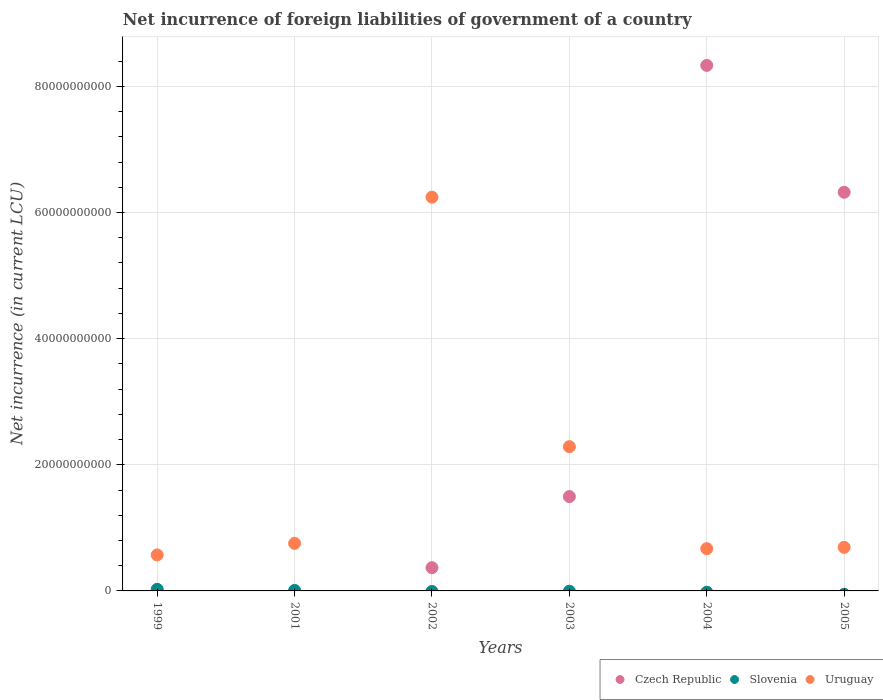Is the number of dotlines equal to the number of legend labels?
Provide a short and direct response. No. What is the net incurrence of foreign liabilities in Uruguay in 2003?
Offer a very short reply. 2.29e+1. Across all years, what is the maximum net incurrence of foreign liabilities in Slovenia?
Provide a succinct answer. 2.56e+08. In which year was the net incurrence of foreign liabilities in Czech Republic maximum?
Your response must be concise. 2004. What is the total net incurrence of foreign liabilities in Uruguay in the graph?
Offer a very short reply. 1.12e+11. What is the difference between the net incurrence of foreign liabilities in Uruguay in 2003 and that in 2005?
Keep it short and to the point. 1.60e+1. What is the difference between the net incurrence of foreign liabilities in Czech Republic in 2002 and the net incurrence of foreign liabilities in Uruguay in 2001?
Make the answer very short. -3.86e+09. What is the average net incurrence of foreign liabilities in Uruguay per year?
Make the answer very short. 1.87e+1. In the year 2005, what is the difference between the net incurrence of foreign liabilities in Czech Republic and net incurrence of foreign liabilities in Uruguay?
Keep it short and to the point. 5.63e+1. What is the ratio of the net incurrence of foreign liabilities in Uruguay in 2001 to that in 2002?
Your answer should be very brief. 0.12. Is the net incurrence of foreign liabilities in Czech Republic in 2002 less than that in 2003?
Offer a terse response. Yes. Is the difference between the net incurrence of foreign liabilities in Czech Republic in 2003 and 2004 greater than the difference between the net incurrence of foreign liabilities in Uruguay in 2003 and 2004?
Your answer should be compact. No. What is the difference between the highest and the second highest net incurrence of foreign liabilities in Czech Republic?
Your answer should be compact. 2.01e+1. What is the difference between the highest and the lowest net incurrence of foreign liabilities in Czech Republic?
Your response must be concise. 8.33e+1. In how many years, is the net incurrence of foreign liabilities in Slovenia greater than the average net incurrence of foreign liabilities in Slovenia taken over all years?
Provide a succinct answer. 2. Is it the case that in every year, the sum of the net incurrence of foreign liabilities in Uruguay and net incurrence of foreign liabilities in Slovenia  is greater than the net incurrence of foreign liabilities in Czech Republic?
Your response must be concise. No. Is the net incurrence of foreign liabilities in Czech Republic strictly less than the net incurrence of foreign liabilities in Slovenia over the years?
Offer a terse response. No. Does the graph contain any zero values?
Give a very brief answer. Yes. How are the legend labels stacked?
Your response must be concise. Horizontal. What is the title of the graph?
Keep it short and to the point. Net incurrence of foreign liabilities of government of a country. What is the label or title of the Y-axis?
Your response must be concise. Net incurrence (in current LCU). What is the Net incurrence (in current LCU) in Czech Republic in 1999?
Provide a short and direct response. 0. What is the Net incurrence (in current LCU) in Slovenia in 1999?
Provide a short and direct response. 2.56e+08. What is the Net incurrence (in current LCU) in Uruguay in 1999?
Offer a terse response. 5.71e+09. What is the Net incurrence (in current LCU) of Slovenia in 2001?
Give a very brief answer. 8.32e+07. What is the Net incurrence (in current LCU) in Uruguay in 2001?
Provide a succinct answer. 7.54e+09. What is the Net incurrence (in current LCU) in Czech Republic in 2002?
Your answer should be compact. 3.68e+09. What is the Net incurrence (in current LCU) of Uruguay in 2002?
Offer a very short reply. 6.24e+1. What is the Net incurrence (in current LCU) in Czech Republic in 2003?
Your response must be concise. 1.50e+1. What is the Net incurrence (in current LCU) of Uruguay in 2003?
Provide a succinct answer. 2.29e+1. What is the Net incurrence (in current LCU) of Czech Republic in 2004?
Offer a terse response. 8.33e+1. What is the Net incurrence (in current LCU) of Uruguay in 2004?
Offer a terse response. 6.70e+09. What is the Net incurrence (in current LCU) of Czech Republic in 2005?
Provide a short and direct response. 6.32e+1. What is the Net incurrence (in current LCU) in Uruguay in 2005?
Provide a succinct answer. 6.91e+09. Across all years, what is the maximum Net incurrence (in current LCU) of Czech Republic?
Keep it short and to the point. 8.33e+1. Across all years, what is the maximum Net incurrence (in current LCU) of Slovenia?
Provide a short and direct response. 2.56e+08. Across all years, what is the maximum Net incurrence (in current LCU) of Uruguay?
Your answer should be very brief. 6.24e+1. Across all years, what is the minimum Net incurrence (in current LCU) in Czech Republic?
Your response must be concise. 0. Across all years, what is the minimum Net incurrence (in current LCU) in Slovenia?
Your answer should be compact. 0. Across all years, what is the minimum Net incurrence (in current LCU) of Uruguay?
Your answer should be compact. 5.71e+09. What is the total Net incurrence (in current LCU) of Czech Republic in the graph?
Provide a succinct answer. 1.65e+11. What is the total Net incurrence (in current LCU) in Slovenia in the graph?
Give a very brief answer. 3.39e+08. What is the total Net incurrence (in current LCU) of Uruguay in the graph?
Offer a terse response. 1.12e+11. What is the difference between the Net incurrence (in current LCU) in Slovenia in 1999 and that in 2001?
Offer a very short reply. 1.73e+08. What is the difference between the Net incurrence (in current LCU) of Uruguay in 1999 and that in 2001?
Provide a short and direct response. -1.83e+09. What is the difference between the Net incurrence (in current LCU) of Uruguay in 1999 and that in 2002?
Your answer should be very brief. -5.67e+1. What is the difference between the Net incurrence (in current LCU) of Uruguay in 1999 and that in 2003?
Your answer should be very brief. -1.72e+1. What is the difference between the Net incurrence (in current LCU) of Uruguay in 1999 and that in 2004?
Your answer should be compact. -9.94e+08. What is the difference between the Net incurrence (in current LCU) in Uruguay in 1999 and that in 2005?
Offer a very short reply. -1.21e+09. What is the difference between the Net incurrence (in current LCU) of Uruguay in 2001 and that in 2002?
Offer a very short reply. -5.49e+1. What is the difference between the Net incurrence (in current LCU) of Uruguay in 2001 and that in 2003?
Provide a short and direct response. -1.53e+1. What is the difference between the Net incurrence (in current LCU) in Uruguay in 2001 and that in 2004?
Provide a succinct answer. 8.39e+08. What is the difference between the Net incurrence (in current LCU) in Uruguay in 2001 and that in 2005?
Your answer should be very brief. 6.27e+08. What is the difference between the Net incurrence (in current LCU) of Czech Republic in 2002 and that in 2003?
Your response must be concise. -1.13e+1. What is the difference between the Net incurrence (in current LCU) of Uruguay in 2002 and that in 2003?
Keep it short and to the point. 3.96e+1. What is the difference between the Net incurrence (in current LCU) in Czech Republic in 2002 and that in 2004?
Make the answer very short. -7.96e+1. What is the difference between the Net incurrence (in current LCU) of Uruguay in 2002 and that in 2004?
Offer a very short reply. 5.57e+1. What is the difference between the Net incurrence (in current LCU) of Czech Republic in 2002 and that in 2005?
Provide a short and direct response. -5.95e+1. What is the difference between the Net incurrence (in current LCU) of Uruguay in 2002 and that in 2005?
Provide a succinct answer. 5.55e+1. What is the difference between the Net incurrence (in current LCU) of Czech Republic in 2003 and that in 2004?
Keep it short and to the point. -6.84e+1. What is the difference between the Net incurrence (in current LCU) of Uruguay in 2003 and that in 2004?
Your response must be concise. 1.62e+1. What is the difference between the Net incurrence (in current LCU) in Czech Republic in 2003 and that in 2005?
Make the answer very short. -4.83e+1. What is the difference between the Net incurrence (in current LCU) of Uruguay in 2003 and that in 2005?
Provide a short and direct response. 1.60e+1. What is the difference between the Net incurrence (in current LCU) of Czech Republic in 2004 and that in 2005?
Make the answer very short. 2.01e+1. What is the difference between the Net incurrence (in current LCU) of Uruguay in 2004 and that in 2005?
Make the answer very short. -2.11e+08. What is the difference between the Net incurrence (in current LCU) of Slovenia in 1999 and the Net incurrence (in current LCU) of Uruguay in 2001?
Offer a very short reply. -7.28e+09. What is the difference between the Net incurrence (in current LCU) of Slovenia in 1999 and the Net incurrence (in current LCU) of Uruguay in 2002?
Your answer should be very brief. -6.22e+1. What is the difference between the Net incurrence (in current LCU) of Slovenia in 1999 and the Net incurrence (in current LCU) of Uruguay in 2003?
Provide a short and direct response. -2.26e+1. What is the difference between the Net incurrence (in current LCU) in Slovenia in 1999 and the Net incurrence (in current LCU) in Uruguay in 2004?
Provide a succinct answer. -6.45e+09. What is the difference between the Net incurrence (in current LCU) of Slovenia in 1999 and the Net incurrence (in current LCU) of Uruguay in 2005?
Your response must be concise. -6.66e+09. What is the difference between the Net incurrence (in current LCU) of Slovenia in 2001 and the Net incurrence (in current LCU) of Uruguay in 2002?
Provide a succinct answer. -6.23e+1. What is the difference between the Net incurrence (in current LCU) in Slovenia in 2001 and the Net incurrence (in current LCU) in Uruguay in 2003?
Your answer should be very brief. -2.28e+1. What is the difference between the Net incurrence (in current LCU) in Slovenia in 2001 and the Net incurrence (in current LCU) in Uruguay in 2004?
Provide a succinct answer. -6.62e+09. What is the difference between the Net incurrence (in current LCU) of Slovenia in 2001 and the Net incurrence (in current LCU) of Uruguay in 2005?
Make the answer very short. -6.83e+09. What is the difference between the Net incurrence (in current LCU) of Czech Republic in 2002 and the Net incurrence (in current LCU) of Uruguay in 2003?
Give a very brief answer. -1.92e+1. What is the difference between the Net incurrence (in current LCU) of Czech Republic in 2002 and the Net incurrence (in current LCU) of Uruguay in 2004?
Keep it short and to the point. -3.02e+09. What is the difference between the Net incurrence (in current LCU) in Czech Republic in 2002 and the Net incurrence (in current LCU) in Uruguay in 2005?
Your response must be concise. -3.23e+09. What is the difference between the Net incurrence (in current LCU) of Czech Republic in 2003 and the Net incurrence (in current LCU) of Uruguay in 2004?
Your answer should be compact. 8.25e+09. What is the difference between the Net incurrence (in current LCU) of Czech Republic in 2003 and the Net incurrence (in current LCU) of Uruguay in 2005?
Keep it short and to the point. 8.04e+09. What is the difference between the Net incurrence (in current LCU) in Czech Republic in 2004 and the Net incurrence (in current LCU) in Uruguay in 2005?
Your response must be concise. 7.64e+1. What is the average Net incurrence (in current LCU) of Czech Republic per year?
Your response must be concise. 2.75e+1. What is the average Net incurrence (in current LCU) in Slovenia per year?
Make the answer very short. 5.66e+07. What is the average Net incurrence (in current LCU) of Uruguay per year?
Your response must be concise. 1.87e+1. In the year 1999, what is the difference between the Net incurrence (in current LCU) in Slovenia and Net incurrence (in current LCU) in Uruguay?
Provide a succinct answer. -5.45e+09. In the year 2001, what is the difference between the Net incurrence (in current LCU) in Slovenia and Net incurrence (in current LCU) in Uruguay?
Provide a succinct answer. -7.46e+09. In the year 2002, what is the difference between the Net incurrence (in current LCU) in Czech Republic and Net incurrence (in current LCU) in Uruguay?
Offer a terse response. -5.88e+1. In the year 2003, what is the difference between the Net incurrence (in current LCU) of Czech Republic and Net incurrence (in current LCU) of Uruguay?
Make the answer very short. -7.92e+09. In the year 2004, what is the difference between the Net incurrence (in current LCU) of Czech Republic and Net incurrence (in current LCU) of Uruguay?
Provide a succinct answer. 7.66e+1. In the year 2005, what is the difference between the Net incurrence (in current LCU) of Czech Republic and Net incurrence (in current LCU) of Uruguay?
Your response must be concise. 5.63e+1. What is the ratio of the Net incurrence (in current LCU) in Slovenia in 1999 to that in 2001?
Your answer should be compact. 3.08. What is the ratio of the Net incurrence (in current LCU) of Uruguay in 1999 to that in 2001?
Provide a short and direct response. 0.76. What is the ratio of the Net incurrence (in current LCU) of Uruguay in 1999 to that in 2002?
Your answer should be very brief. 0.09. What is the ratio of the Net incurrence (in current LCU) of Uruguay in 1999 to that in 2003?
Provide a short and direct response. 0.25. What is the ratio of the Net incurrence (in current LCU) of Uruguay in 1999 to that in 2004?
Ensure brevity in your answer.  0.85. What is the ratio of the Net incurrence (in current LCU) in Uruguay in 1999 to that in 2005?
Provide a succinct answer. 0.83. What is the ratio of the Net incurrence (in current LCU) of Uruguay in 2001 to that in 2002?
Ensure brevity in your answer.  0.12. What is the ratio of the Net incurrence (in current LCU) of Uruguay in 2001 to that in 2003?
Make the answer very short. 0.33. What is the ratio of the Net incurrence (in current LCU) of Uruguay in 2001 to that in 2004?
Your response must be concise. 1.13. What is the ratio of the Net incurrence (in current LCU) of Uruguay in 2001 to that in 2005?
Provide a short and direct response. 1.09. What is the ratio of the Net incurrence (in current LCU) of Czech Republic in 2002 to that in 2003?
Make the answer very short. 0.25. What is the ratio of the Net incurrence (in current LCU) of Uruguay in 2002 to that in 2003?
Ensure brevity in your answer.  2.73. What is the ratio of the Net incurrence (in current LCU) of Czech Republic in 2002 to that in 2004?
Provide a succinct answer. 0.04. What is the ratio of the Net incurrence (in current LCU) of Uruguay in 2002 to that in 2004?
Keep it short and to the point. 9.32. What is the ratio of the Net incurrence (in current LCU) of Czech Republic in 2002 to that in 2005?
Ensure brevity in your answer.  0.06. What is the ratio of the Net incurrence (in current LCU) in Uruguay in 2002 to that in 2005?
Give a very brief answer. 9.03. What is the ratio of the Net incurrence (in current LCU) in Czech Republic in 2003 to that in 2004?
Offer a terse response. 0.18. What is the ratio of the Net incurrence (in current LCU) in Uruguay in 2003 to that in 2004?
Ensure brevity in your answer.  3.41. What is the ratio of the Net incurrence (in current LCU) of Czech Republic in 2003 to that in 2005?
Your response must be concise. 0.24. What is the ratio of the Net incurrence (in current LCU) in Uruguay in 2003 to that in 2005?
Offer a terse response. 3.31. What is the ratio of the Net incurrence (in current LCU) of Czech Republic in 2004 to that in 2005?
Provide a succinct answer. 1.32. What is the ratio of the Net incurrence (in current LCU) in Uruguay in 2004 to that in 2005?
Your response must be concise. 0.97. What is the difference between the highest and the second highest Net incurrence (in current LCU) in Czech Republic?
Keep it short and to the point. 2.01e+1. What is the difference between the highest and the second highest Net incurrence (in current LCU) of Uruguay?
Keep it short and to the point. 3.96e+1. What is the difference between the highest and the lowest Net incurrence (in current LCU) of Czech Republic?
Your answer should be very brief. 8.33e+1. What is the difference between the highest and the lowest Net incurrence (in current LCU) in Slovenia?
Your answer should be very brief. 2.56e+08. What is the difference between the highest and the lowest Net incurrence (in current LCU) in Uruguay?
Offer a very short reply. 5.67e+1. 